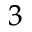Convert formula to latex. <formula><loc_0><loc_0><loc_500><loc_500>^ { 3 }</formula> 